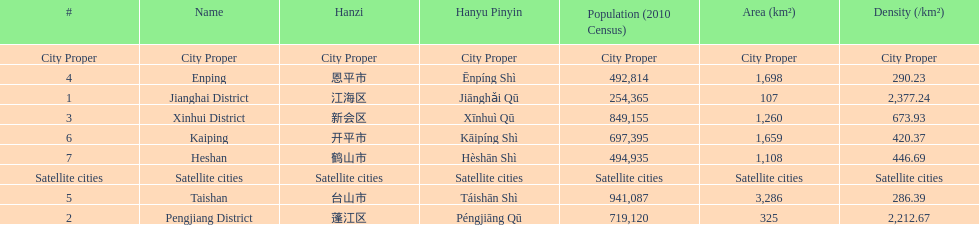What is the most populated district? Taishan. 